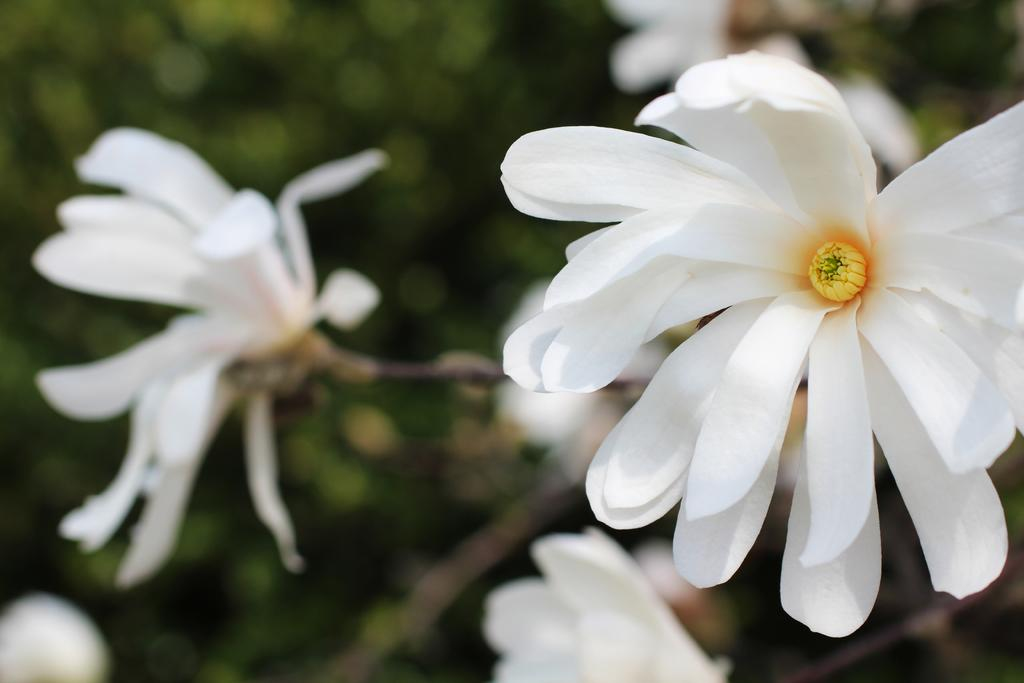What type of flower is on the right side of the image? There is a white flower on the right side of the image. What else can be seen in the background of the image? There are flowers and greenery in the background of the image. What type of coal is visible in the image? There is no coal present in the image. What kind of system is being used to grow the flowers in the image? The image does not provide information about any system being used to grow the flowers. 